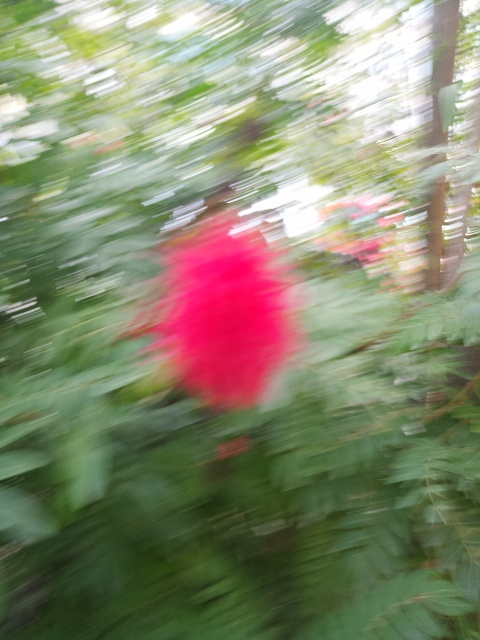Despite the blur, can you deduce anything about the setting of this image? Although details are indistinct, the general color scheme of green with what appears to be floral color suggests an outdoor or garden setting. It could be a park or a backyard where flowers are present, and the overall impression is one of a lush, vegetative environment. What time of day do you think it is? Determining the exact time of day from a blurred image is difficult, but the lighting appears to be natural and reasonably bright, suggesting daytime. The absence of shadows or warm light that you might see during golden hours (shortly after sunrise or before sunset) hints at a time outside of those periods. 